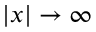Convert formula to latex. <formula><loc_0><loc_0><loc_500><loc_500>| x | \rightarrow \infty</formula> 